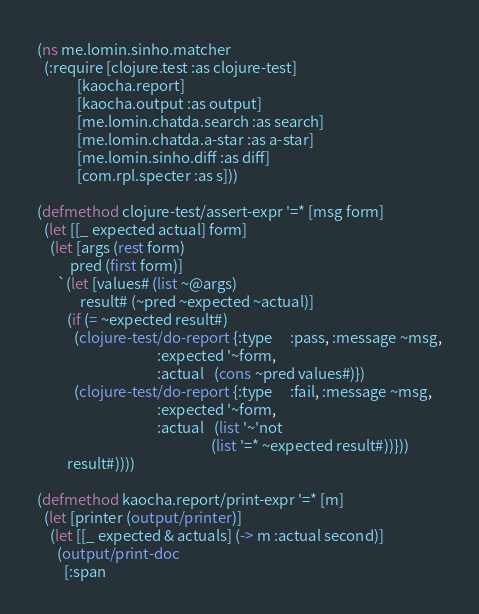<code> <loc_0><loc_0><loc_500><loc_500><_Clojure_>(ns me.lomin.sinho.matcher
  (:require [clojure.test :as clojure-test]
            [kaocha.report]
            [kaocha.output :as output]
            [me.lomin.chatda.search :as search]
            [me.lomin.chatda.a-star :as a-star]
            [me.lomin.sinho.diff :as diff]
            [com.rpl.specter :as s]))

(defmethod clojure-test/assert-expr '=* [msg form]
  (let [[_ expected actual] form]
    (let [args (rest form)
          pred (first form)]
      `(let [values# (list ~@args)
             result# (~pred ~expected ~actual)]
         (if (= ~expected result#)
           (clojure-test/do-report {:type     :pass, :message ~msg,
                                    :expected '~form,
                                    :actual   (cons ~pred values#)})
           (clojure-test/do-report {:type     :fail, :message ~msg,
                                    :expected '~form,
                                    :actual   (list '~'not
                                                    (list '=* ~expected result#))}))
         result#))))

(defmethod kaocha.report/print-expr '=* [m]
  (let [printer (output/printer)]
    (let [[_ expected & actuals] (-> m :actual second)]
      (output/print-doc
        [:span</code> 